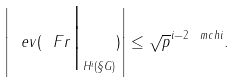<formula> <loc_0><loc_0><loc_500><loc_500>\left | \ e v ( \ F r \Big { | } _ { H ^ { i } ( \S G ) } ) \right | \leq \sqrt { p } ^ { i - 2 \ m c h i } .</formula> 